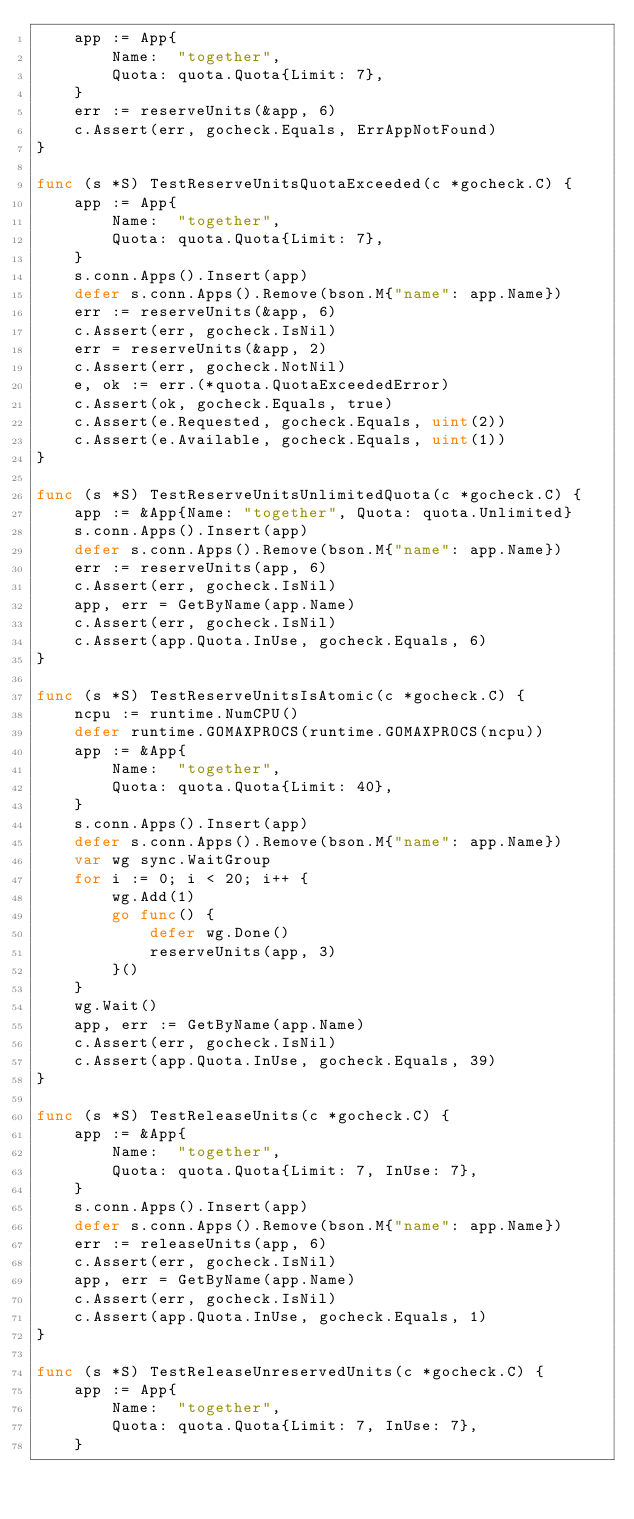<code> <loc_0><loc_0><loc_500><loc_500><_Go_>	app := App{
		Name:  "together",
		Quota: quota.Quota{Limit: 7},
	}
	err := reserveUnits(&app, 6)
	c.Assert(err, gocheck.Equals, ErrAppNotFound)
}

func (s *S) TestReserveUnitsQuotaExceeded(c *gocheck.C) {
	app := App{
		Name:  "together",
		Quota: quota.Quota{Limit: 7},
	}
	s.conn.Apps().Insert(app)
	defer s.conn.Apps().Remove(bson.M{"name": app.Name})
	err := reserveUnits(&app, 6)
	c.Assert(err, gocheck.IsNil)
	err = reserveUnits(&app, 2)
	c.Assert(err, gocheck.NotNil)
	e, ok := err.(*quota.QuotaExceededError)
	c.Assert(ok, gocheck.Equals, true)
	c.Assert(e.Requested, gocheck.Equals, uint(2))
	c.Assert(e.Available, gocheck.Equals, uint(1))
}

func (s *S) TestReserveUnitsUnlimitedQuota(c *gocheck.C) {
	app := &App{Name: "together", Quota: quota.Unlimited}
	s.conn.Apps().Insert(app)
	defer s.conn.Apps().Remove(bson.M{"name": app.Name})
	err := reserveUnits(app, 6)
	c.Assert(err, gocheck.IsNil)
	app, err = GetByName(app.Name)
	c.Assert(err, gocheck.IsNil)
	c.Assert(app.Quota.InUse, gocheck.Equals, 6)
}

func (s *S) TestReserveUnitsIsAtomic(c *gocheck.C) {
	ncpu := runtime.NumCPU()
	defer runtime.GOMAXPROCS(runtime.GOMAXPROCS(ncpu))
	app := &App{
		Name:  "together",
		Quota: quota.Quota{Limit: 40},
	}
	s.conn.Apps().Insert(app)
	defer s.conn.Apps().Remove(bson.M{"name": app.Name})
	var wg sync.WaitGroup
	for i := 0; i < 20; i++ {
		wg.Add(1)
		go func() {
			defer wg.Done()
			reserveUnits(app, 3)
		}()
	}
	wg.Wait()
	app, err := GetByName(app.Name)
	c.Assert(err, gocheck.IsNil)
	c.Assert(app.Quota.InUse, gocheck.Equals, 39)
}

func (s *S) TestReleaseUnits(c *gocheck.C) {
	app := &App{
		Name:  "together",
		Quota: quota.Quota{Limit: 7, InUse: 7},
	}
	s.conn.Apps().Insert(app)
	defer s.conn.Apps().Remove(bson.M{"name": app.Name})
	err := releaseUnits(app, 6)
	c.Assert(err, gocheck.IsNil)
	app, err = GetByName(app.Name)
	c.Assert(err, gocheck.IsNil)
	c.Assert(app.Quota.InUse, gocheck.Equals, 1)
}

func (s *S) TestReleaseUnreservedUnits(c *gocheck.C) {
	app := App{
		Name:  "together",
		Quota: quota.Quota{Limit: 7, InUse: 7},
	}</code> 